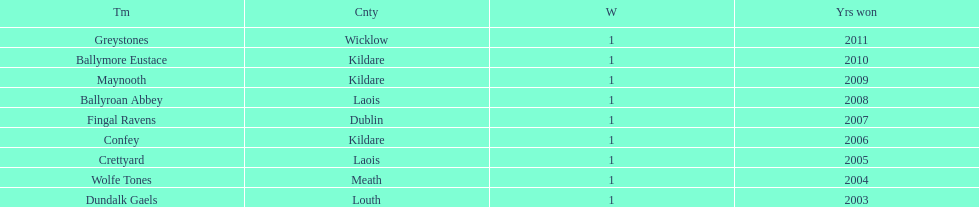What is the total of wins on the chart 9. 